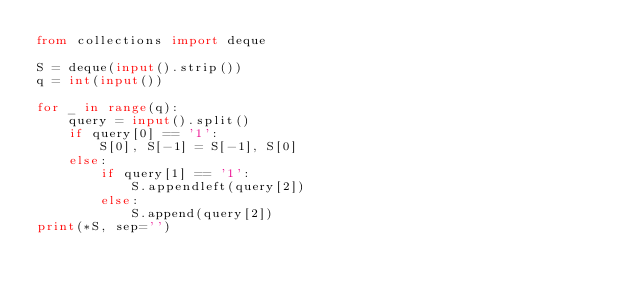Convert code to text. <code><loc_0><loc_0><loc_500><loc_500><_Python_>from collections import deque

S = deque(input().strip())
q = int(input())

for _ in range(q):
    query = input().split()
    if query[0] == '1':
        S[0], S[-1] = S[-1], S[0]
    else:
        if query[1] == '1':
            S.appendleft(query[2])
        else:
            S.append(query[2])
print(*S, sep='')</code> 